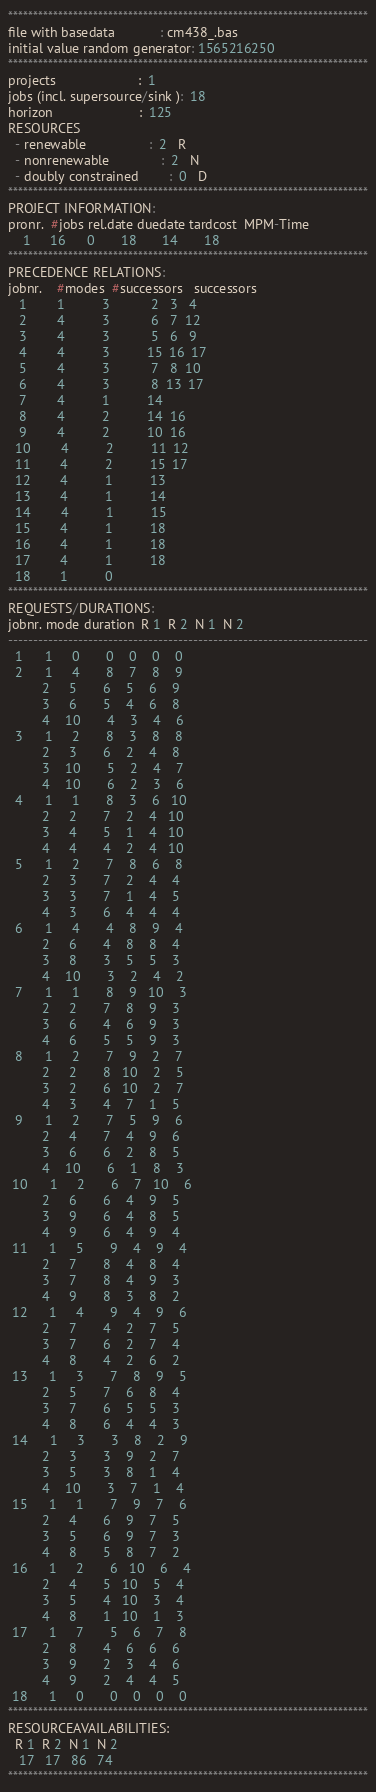<code> <loc_0><loc_0><loc_500><loc_500><_ObjectiveC_>************************************************************************
file with basedata            : cm438_.bas
initial value random generator: 1565216250
************************************************************************
projects                      :  1
jobs (incl. supersource/sink ):  18
horizon                       :  125
RESOURCES
  - renewable                 :  2   R
  - nonrenewable              :  2   N
  - doubly constrained        :  0   D
************************************************************************
PROJECT INFORMATION:
pronr.  #jobs rel.date duedate tardcost  MPM-Time
    1     16      0       18       14       18
************************************************************************
PRECEDENCE RELATIONS:
jobnr.    #modes  #successors   successors
   1        1          3           2   3   4
   2        4          3           6   7  12
   3        4          3           5   6   9
   4        4          3          15  16  17
   5        4          3           7   8  10
   6        4          3           8  13  17
   7        4          1          14
   8        4          2          14  16
   9        4          2          10  16
  10        4          2          11  12
  11        4          2          15  17
  12        4          1          13
  13        4          1          14
  14        4          1          15
  15        4          1          18
  16        4          1          18
  17        4          1          18
  18        1          0        
************************************************************************
REQUESTS/DURATIONS:
jobnr. mode duration  R 1  R 2  N 1  N 2
------------------------------------------------------------------------
  1      1     0       0    0    0    0
  2      1     4       8    7    8    9
         2     5       6    5    6    9
         3     6       5    4    6    8
         4    10       4    3    4    6
  3      1     2       8    3    8    8
         2     3       6    2    4    8
         3    10       5    2    4    7
         4    10       6    2    3    6
  4      1     1       8    3    6   10
         2     2       7    2    4   10
         3     4       5    1    4   10
         4     4       4    2    4   10
  5      1     2       7    8    6    8
         2     3       7    2    4    4
         3     3       7    1    4    5
         4     3       6    4    4    4
  6      1     4       4    8    9    4
         2     6       4    8    8    4
         3     8       3    5    5    3
         4    10       3    2    4    2
  7      1     1       8    9   10    3
         2     2       7    8    9    3
         3     6       4    6    9    3
         4     6       5    5    9    3
  8      1     2       7    9    2    7
         2     2       8   10    2    5
         3     2       6   10    2    7
         4     3       4    7    1    5
  9      1     2       7    5    9    6
         2     4       7    4    9    6
         3     6       6    2    8    5
         4    10       6    1    8    3
 10      1     2       6    7   10    6
         2     6       6    4    9    5
         3     9       6    4    8    5
         4     9       6    4    9    4
 11      1     5       9    4    9    4
         2     7       8    4    8    4
         3     7       8    4    9    3
         4     9       8    3    8    2
 12      1     4       9    4    9    6
         2     7       4    2    7    5
         3     7       6    2    7    4
         4     8       4    2    6    2
 13      1     3       7    8    9    5
         2     5       7    6    8    4
         3     7       6    5    5    3
         4     8       6    4    4    3
 14      1     3       3    8    2    9
         2     3       3    9    2    7
         3     5       3    8    1    4
         4    10       3    7    1    4
 15      1     1       7    9    7    6
         2     4       6    9    7    5
         3     5       6    9    7    3
         4     8       5    8    7    2
 16      1     2       6   10    6    4
         2     4       5   10    5    4
         3     5       4   10    3    4
         4     8       1   10    1    3
 17      1     7       5    6    7    8
         2     8       4    6    6    6
         3     9       2    3    4    6
         4     9       2    4    4    5
 18      1     0       0    0    0    0
************************************************************************
RESOURCEAVAILABILITIES:
  R 1  R 2  N 1  N 2
   17   17   86   74
************************************************************************
</code> 